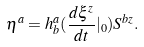Convert formula to latex. <formula><loc_0><loc_0><loc_500><loc_500>\eta ^ { a } = h _ { b } ^ { a } ( \frac { d \xi ^ { z } } { d t } | _ { 0 } ) S ^ { b z } .</formula> 